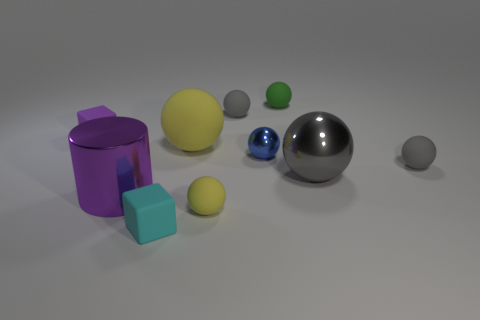There is another tiny rubber object that is the same shape as the small cyan thing; what is its color?
Make the answer very short. Purple. The green ball is what size?
Offer a very short reply. Small. How many yellow spheres have the same size as the shiny cylinder?
Ensure brevity in your answer.  1. Does the shiny cylinder have the same color as the big rubber sphere?
Offer a very short reply. No. Are the big ball that is behind the small blue metal sphere and the gray sphere that is behind the tiny purple object made of the same material?
Your answer should be compact. Yes. Are there more gray metallic balls than small red shiny blocks?
Keep it short and to the point. Yes. Are there any other things that have the same color as the large shiny sphere?
Your answer should be compact. Yes. Are the blue ball and the cyan object made of the same material?
Provide a succinct answer. No. Is the number of big cubes less than the number of large spheres?
Your answer should be very brief. Yes. Is the large purple metal object the same shape as the small green matte object?
Make the answer very short. No. 